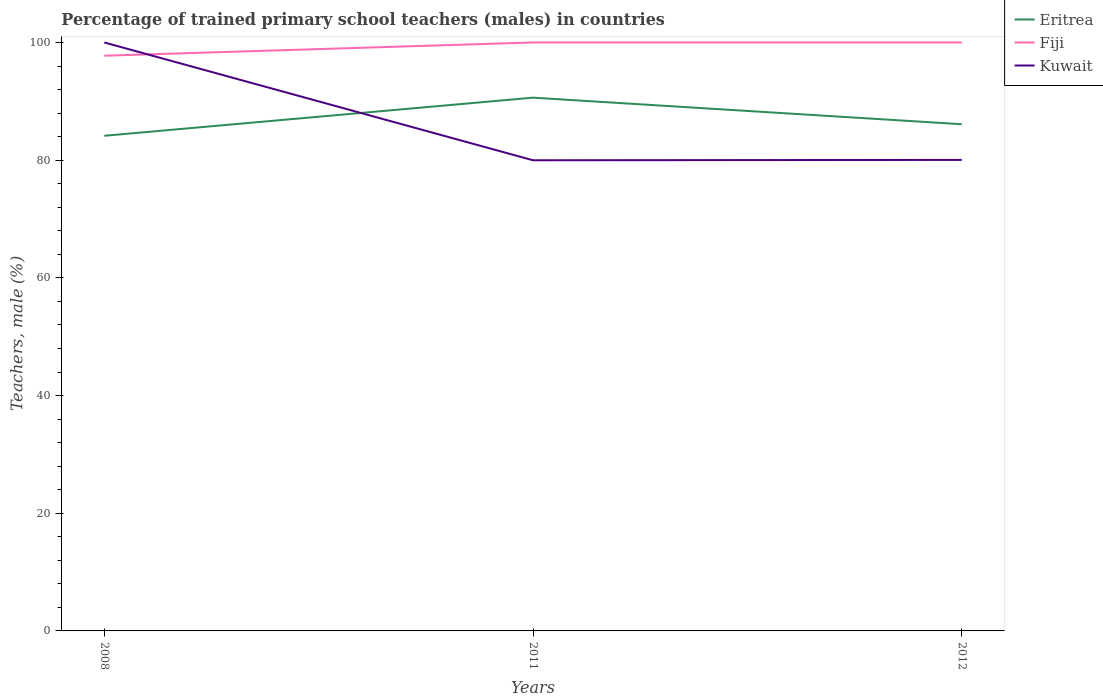How many different coloured lines are there?
Make the answer very short. 3. Does the line corresponding to Fiji intersect with the line corresponding to Eritrea?
Keep it short and to the point. No. Across all years, what is the maximum percentage of trained primary school teachers (males) in Fiji?
Your answer should be compact. 97.75. What is the total percentage of trained primary school teachers (males) in Kuwait in the graph?
Provide a short and direct response. 19.96. What is the difference between the highest and the second highest percentage of trained primary school teachers (males) in Fiji?
Offer a very short reply. 2.25. What is the difference between the highest and the lowest percentage of trained primary school teachers (males) in Eritrea?
Make the answer very short. 1. Are the values on the major ticks of Y-axis written in scientific E-notation?
Your answer should be very brief. No. Does the graph contain any zero values?
Offer a very short reply. No. Does the graph contain grids?
Offer a very short reply. No. Where does the legend appear in the graph?
Ensure brevity in your answer.  Top right. How many legend labels are there?
Provide a short and direct response. 3. What is the title of the graph?
Give a very brief answer. Percentage of trained primary school teachers (males) in countries. What is the label or title of the X-axis?
Make the answer very short. Years. What is the label or title of the Y-axis?
Offer a terse response. Teachers, male (%). What is the Teachers, male (%) in Eritrea in 2008?
Provide a short and direct response. 84.14. What is the Teachers, male (%) of Fiji in 2008?
Your answer should be compact. 97.75. What is the Teachers, male (%) of Kuwait in 2008?
Make the answer very short. 100. What is the Teachers, male (%) in Eritrea in 2011?
Your response must be concise. 90.62. What is the Teachers, male (%) of Fiji in 2011?
Your answer should be very brief. 100. What is the Teachers, male (%) in Kuwait in 2011?
Ensure brevity in your answer.  79.98. What is the Teachers, male (%) of Eritrea in 2012?
Your answer should be very brief. 86.11. What is the Teachers, male (%) of Kuwait in 2012?
Ensure brevity in your answer.  80.04. Across all years, what is the maximum Teachers, male (%) of Eritrea?
Provide a succinct answer. 90.62. Across all years, what is the minimum Teachers, male (%) of Eritrea?
Keep it short and to the point. 84.14. Across all years, what is the minimum Teachers, male (%) of Fiji?
Provide a short and direct response. 97.75. Across all years, what is the minimum Teachers, male (%) in Kuwait?
Give a very brief answer. 79.98. What is the total Teachers, male (%) of Eritrea in the graph?
Make the answer very short. 260.87. What is the total Teachers, male (%) in Fiji in the graph?
Your response must be concise. 297.75. What is the total Teachers, male (%) in Kuwait in the graph?
Your answer should be compact. 260.02. What is the difference between the Teachers, male (%) in Eritrea in 2008 and that in 2011?
Your answer should be compact. -6.48. What is the difference between the Teachers, male (%) of Fiji in 2008 and that in 2011?
Provide a short and direct response. -2.25. What is the difference between the Teachers, male (%) of Kuwait in 2008 and that in 2011?
Keep it short and to the point. 20.02. What is the difference between the Teachers, male (%) of Eritrea in 2008 and that in 2012?
Offer a terse response. -1.97. What is the difference between the Teachers, male (%) of Fiji in 2008 and that in 2012?
Keep it short and to the point. -2.25. What is the difference between the Teachers, male (%) of Kuwait in 2008 and that in 2012?
Your answer should be very brief. 19.96. What is the difference between the Teachers, male (%) of Eritrea in 2011 and that in 2012?
Keep it short and to the point. 4.51. What is the difference between the Teachers, male (%) in Kuwait in 2011 and that in 2012?
Make the answer very short. -0.06. What is the difference between the Teachers, male (%) of Eritrea in 2008 and the Teachers, male (%) of Fiji in 2011?
Offer a very short reply. -15.86. What is the difference between the Teachers, male (%) of Eritrea in 2008 and the Teachers, male (%) of Kuwait in 2011?
Your answer should be very brief. 4.16. What is the difference between the Teachers, male (%) of Fiji in 2008 and the Teachers, male (%) of Kuwait in 2011?
Provide a short and direct response. 17.77. What is the difference between the Teachers, male (%) in Eritrea in 2008 and the Teachers, male (%) in Fiji in 2012?
Keep it short and to the point. -15.86. What is the difference between the Teachers, male (%) of Eritrea in 2008 and the Teachers, male (%) of Kuwait in 2012?
Keep it short and to the point. 4.1. What is the difference between the Teachers, male (%) in Fiji in 2008 and the Teachers, male (%) in Kuwait in 2012?
Your response must be concise. 17.71. What is the difference between the Teachers, male (%) of Eritrea in 2011 and the Teachers, male (%) of Fiji in 2012?
Provide a succinct answer. -9.38. What is the difference between the Teachers, male (%) of Eritrea in 2011 and the Teachers, male (%) of Kuwait in 2012?
Give a very brief answer. 10.58. What is the difference between the Teachers, male (%) of Fiji in 2011 and the Teachers, male (%) of Kuwait in 2012?
Your answer should be compact. 19.96. What is the average Teachers, male (%) of Eritrea per year?
Offer a very short reply. 86.96. What is the average Teachers, male (%) of Fiji per year?
Give a very brief answer. 99.25. What is the average Teachers, male (%) of Kuwait per year?
Give a very brief answer. 86.67. In the year 2008, what is the difference between the Teachers, male (%) in Eritrea and Teachers, male (%) in Fiji?
Offer a terse response. -13.61. In the year 2008, what is the difference between the Teachers, male (%) of Eritrea and Teachers, male (%) of Kuwait?
Ensure brevity in your answer.  -15.86. In the year 2008, what is the difference between the Teachers, male (%) in Fiji and Teachers, male (%) in Kuwait?
Your response must be concise. -2.25. In the year 2011, what is the difference between the Teachers, male (%) in Eritrea and Teachers, male (%) in Fiji?
Offer a very short reply. -9.38. In the year 2011, what is the difference between the Teachers, male (%) of Eritrea and Teachers, male (%) of Kuwait?
Offer a very short reply. 10.64. In the year 2011, what is the difference between the Teachers, male (%) of Fiji and Teachers, male (%) of Kuwait?
Offer a very short reply. 20.02. In the year 2012, what is the difference between the Teachers, male (%) of Eritrea and Teachers, male (%) of Fiji?
Provide a short and direct response. -13.89. In the year 2012, what is the difference between the Teachers, male (%) of Eritrea and Teachers, male (%) of Kuwait?
Offer a terse response. 6.06. In the year 2012, what is the difference between the Teachers, male (%) in Fiji and Teachers, male (%) in Kuwait?
Provide a short and direct response. 19.96. What is the ratio of the Teachers, male (%) of Eritrea in 2008 to that in 2011?
Make the answer very short. 0.93. What is the ratio of the Teachers, male (%) in Fiji in 2008 to that in 2011?
Provide a succinct answer. 0.98. What is the ratio of the Teachers, male (%) in Kuwait in 2008 to that in 2011?
Provide a short and direct response. 1.25. What is the ratio of the Teachers, male (%) of Eritrea in 2008 to that in 2012?
Give a very brief answer. 0.98. What is the ratio of the Teachers, male (%) of Fiji in 2008 to that in 2012?
Make the answer very short. 0.98. What is the ratio of the Teachers, male (%) of Kuwait in 2008 to that in 2012?
Your answer should be compact. 1.25. What is the ratio of the Teachers, male (%) in Eritrea in 2011 to that in 2012?
Your answer should be compact. 1.05. What is the ratio of the Teachers, male (%) of Fiji in 2011 to that in 2012?
Make the answer very short. 1. What is the difference between the highest and the second highest Teachers, male (%) in Eritrea?
Provide a succinct answer. 4.51. What is the difference between the highest and the second highest Teachers, male (%) in Fiji?
Your response must be concise. 0. What is the difference between the highest and the second highest Teachers, male (%) of Kuwait?
Your answer should be compact. 19.96. What is the difference between the highest and the lowest Teachers, male (%) in Eritrea?
Your answer should be compact. 6.48. What is the difference between the highest and the lowest Teachers, male (%) of Fiji?
Offer a terse response. 2.25. What is the difference between the highest and the lowest Teachers, male (%) in Kuwait?
Offer a terse response. 20.02. 